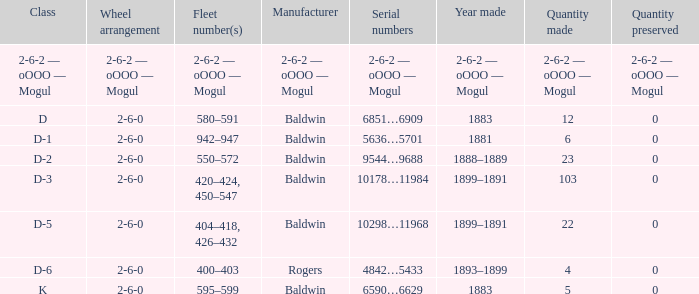Could you parse the entire table? {'header': ['Class', 'Wheel arrangement', 'Fleet number(s)', 'Manufacturer', 'Serial numbers', 'Year made', 'Quantity made', 'Quantity preserved'], 'rows': [['2-6-2 — oOOO — Mogul', '2-6-2 — oOOO — Mogul', '2-6-2 — oOOO — Mogul', '2-6-2 — oOOO — Mogul', '2-6-2 — oOOO — Mogul', '2-6-2 — oOOO — Mogul', '2-6-2 — oOOO — Mogul', '2-6-2 — oOOO — Mogul'], ['D', '2-6-0', '580–591', 'Baldwin', '6851…6909', '1883', '12', '0'], ['D-1', '2-6-0', '942–947', 'Baldwin', '5636…5701', '1881', '6', '0'], ['D-2', '2-6-0', '550–572', 'Baldwin', '9544…9688', '1888–1889', '23', '0'], ['D-3', '2-6-0', '420–424, 450–547', 'Baldwin', '10178…11984', '1899–1891', '103', '0'], ['D-5', '2-6-0', '404–418, 426–432', 'Baldwin', '10298…11968', '1899–1891', '22', '0'], ['D-6', '2-6-0', '400–403', 'Rogers', '4842…5433', '1893–1899', '4', '0'], ['K', '2-6-0', '595–599', 'Baldwin', '6590…6629', '1883', '5', '0']]} What is the category when 0 quantity is preserved and 5 quantities are produced? K. 